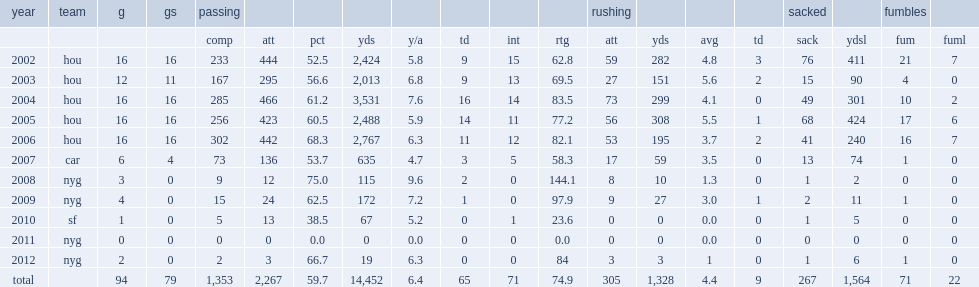How many yards did david carr pass for, in 2004? 3531.0. 